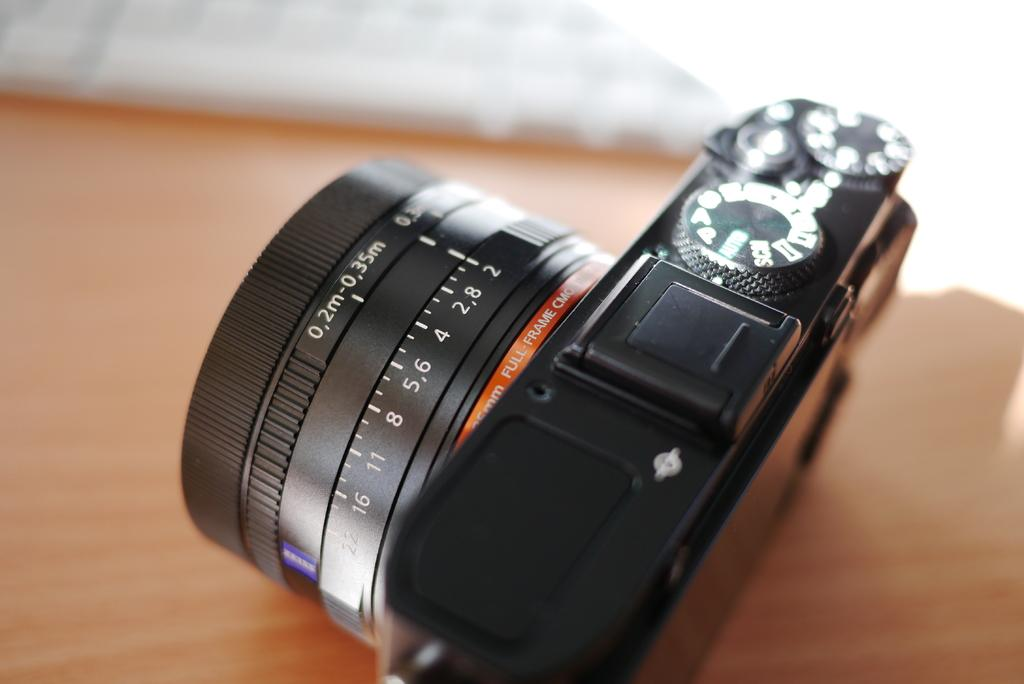<image>
Offer a succinct explanation of the picture presented. A camera with an orange band that says Full-Frame on it. 